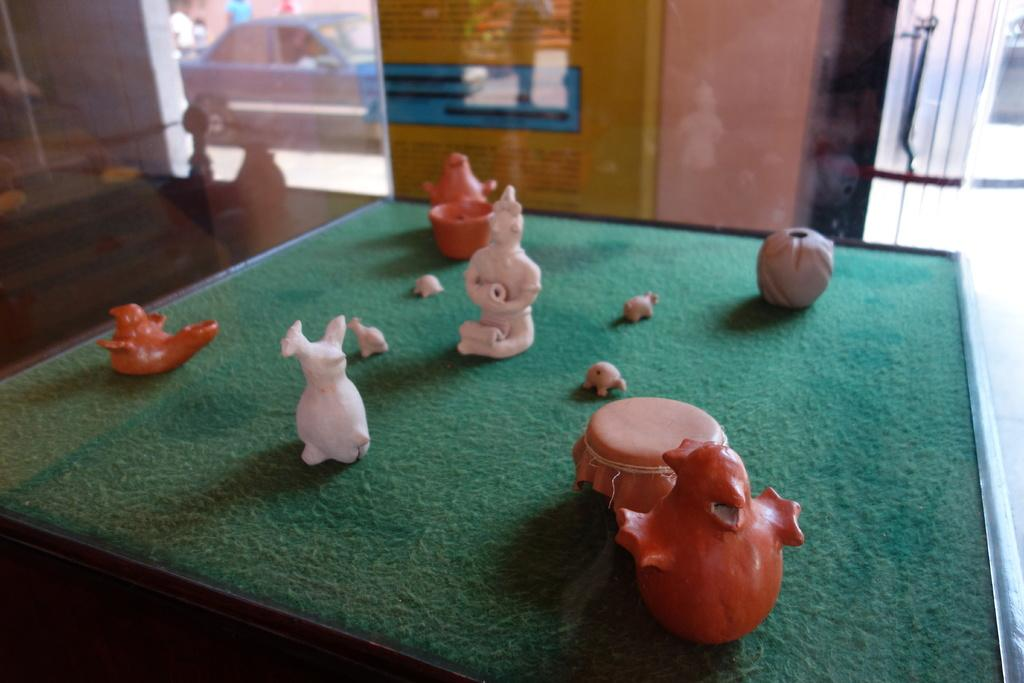What objects are on the table in the image? There are toys on a table in the image. What can be seen in the background of the image? There is a glass and a car on the road in the background. What type of comb is being used to design the bed in the image? There is no comb or bed present in the image. 